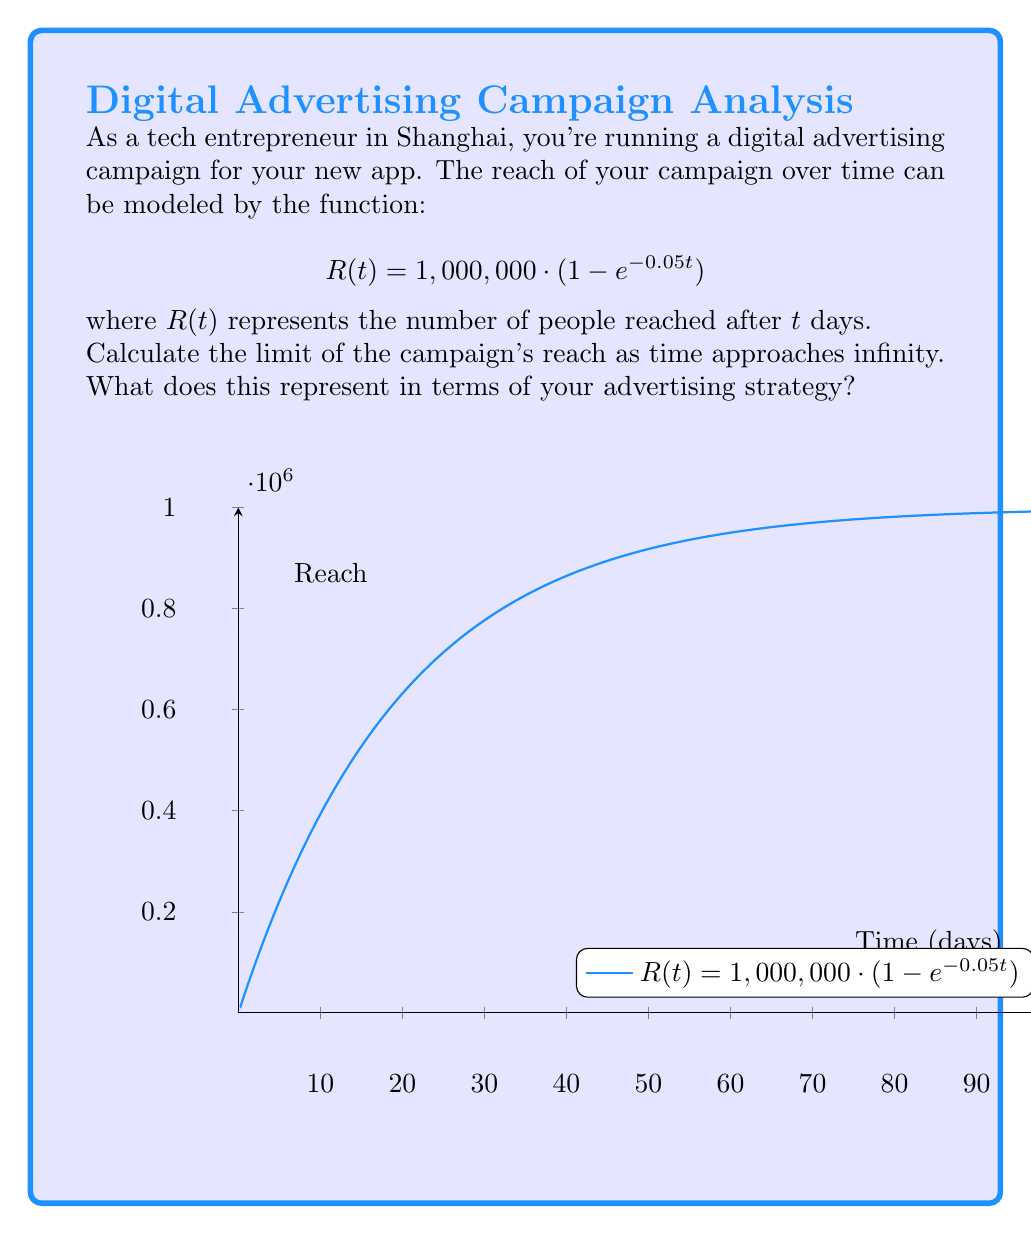Solve this math problem. To solve this problem, we need to calculate the limit of $R(t)$ as $t$ approaches infinity:

1) First, let's write out the limit we're trying to calculate:
   $$\lim_{t \to \infty} R(t) = \lim_{t \to \infty} 1,000,000 \cdot (1 - e^{-0.05t})$$

2) We can factor out the constant:
   $$\lim_{t \to \infty} R(t) = 1,000,000 \cdot \lim_{t \to \infty} (1 - e^{-0.05t})$$

3) Now, let's focus on the limit of $e^{-0.05t}$ as $t$ approaches infinity:
   $$\lim_{t \to \infty} e^{-0.05t} = 0$$
   This is because as $t$ gets very large, $-0.05t$ becomes a large negative number, and $e$ raised to a large negative power approaches zero.

4) Substituting this back into our original limit:
   $$\lim_{t \to \infty} R(t) = 1,000,000 \cdot (1 - 0) = 1,000,000$$

5) Interpretation: This limit represents the maximum potential reach of your advertising campaign. As time goes on, your campaign will approach but never quite reach 1,000,000 people. This is known as the asymptotic value or carrying capacity of your campaign's reach.
Answer: 1,000,000 